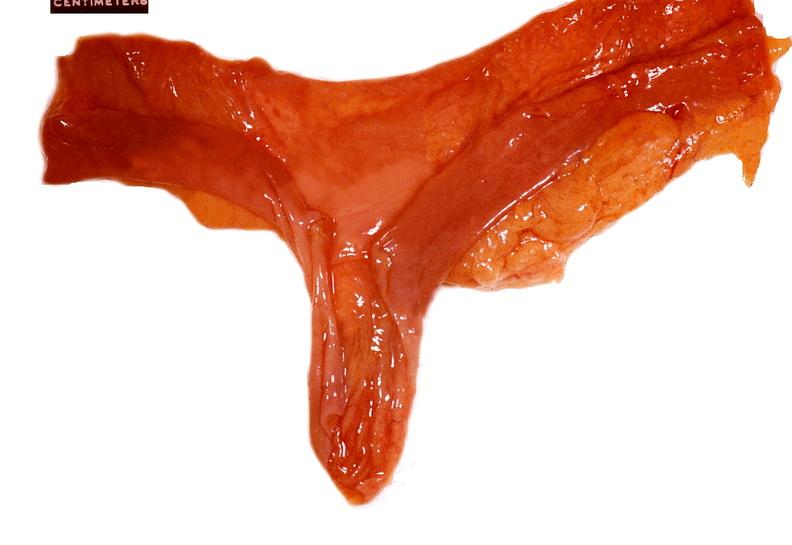s gastrointestinal present?
Answer the question using a single word or phrase. Yes 